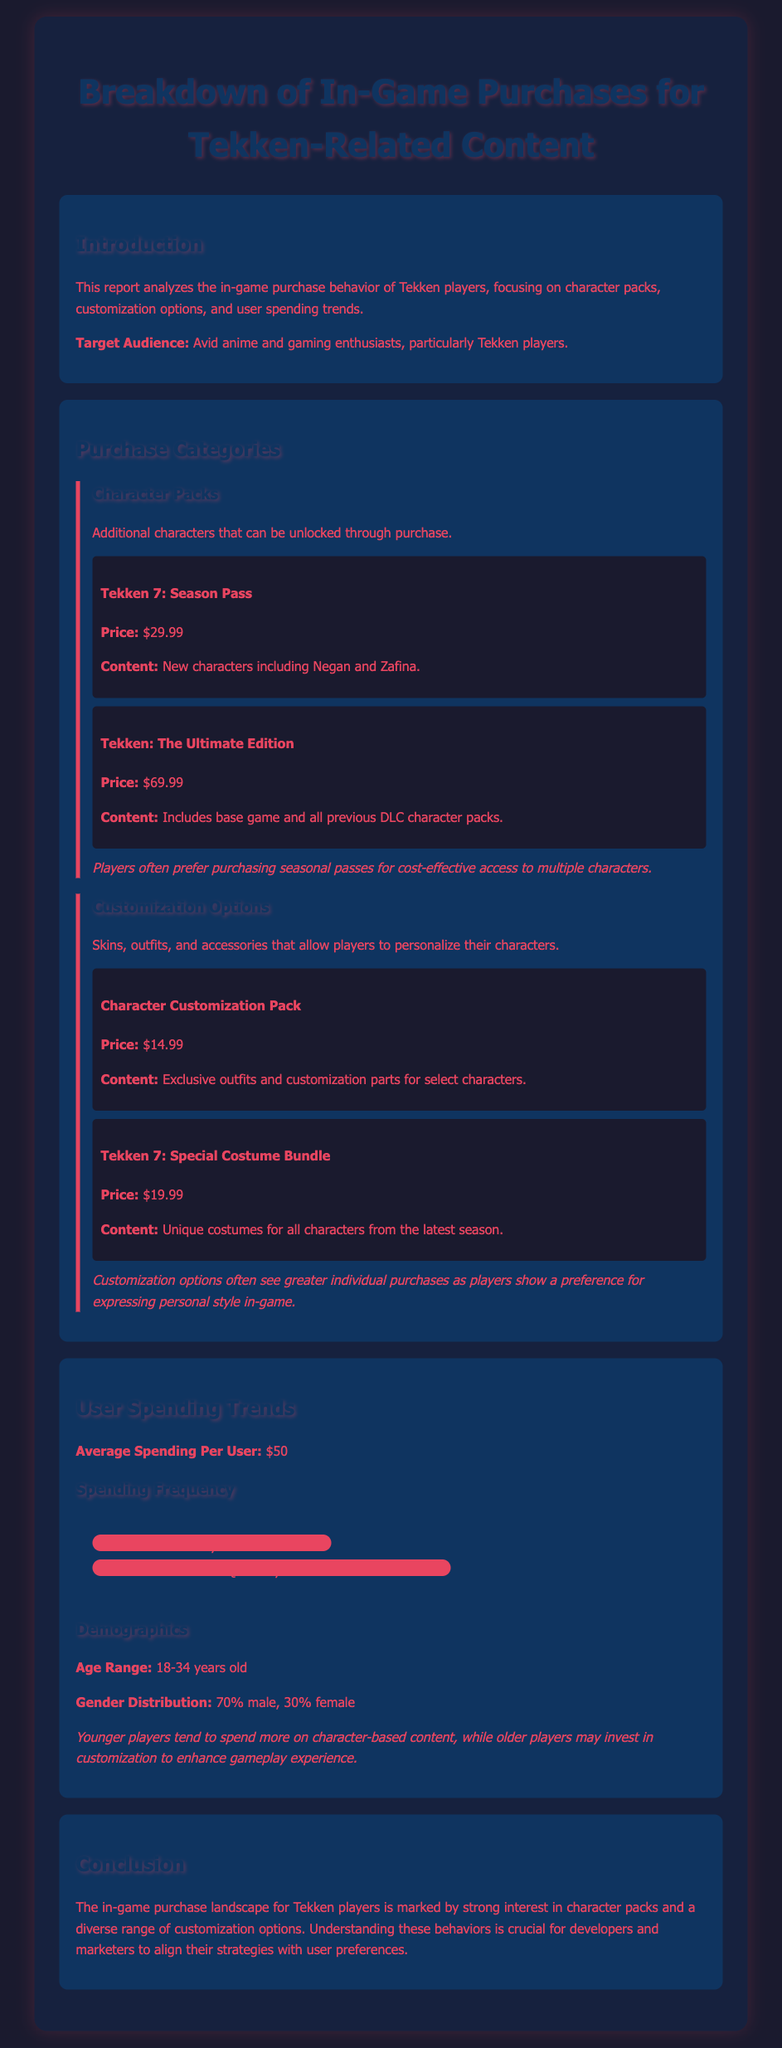What is the price of the Tekken 7: Season Pass? The price of the Tekken 7: Season Pass is mentioned as $29.99.
Answer: $29.99 What percentage of users spend monthly? The document states that 40% of users spend monthly.
Answer: 40% What is the price of the Character Customization Pack? The price for the Character Customization Pack is specified as $14.99.
Answer: $14.99 What age range do most users belong to? The age range of most users is indicated as 18-34 years old.
Answer: 18-34 years old What is the average spending per user? The average spending per user is stated as $50.
Answer: $50 What type of content do younger players prefer? Younger players tend to spend more on character-based content.
Answer: Character-based content Which category do players show a preference for when personalizing characters? Players show a preference for customization options.
Answer: Customization options What is the gender distribution of the Tekken player base? The gender distribution is noted to be 70% male and 30% female.
Answer: 70% male, 30% female What is the price of the Tekken 7: Special Costume Bundle? The price of the Tekken 7: Special Costume Bundle is reported as $19.99.
Answer: $19.99 